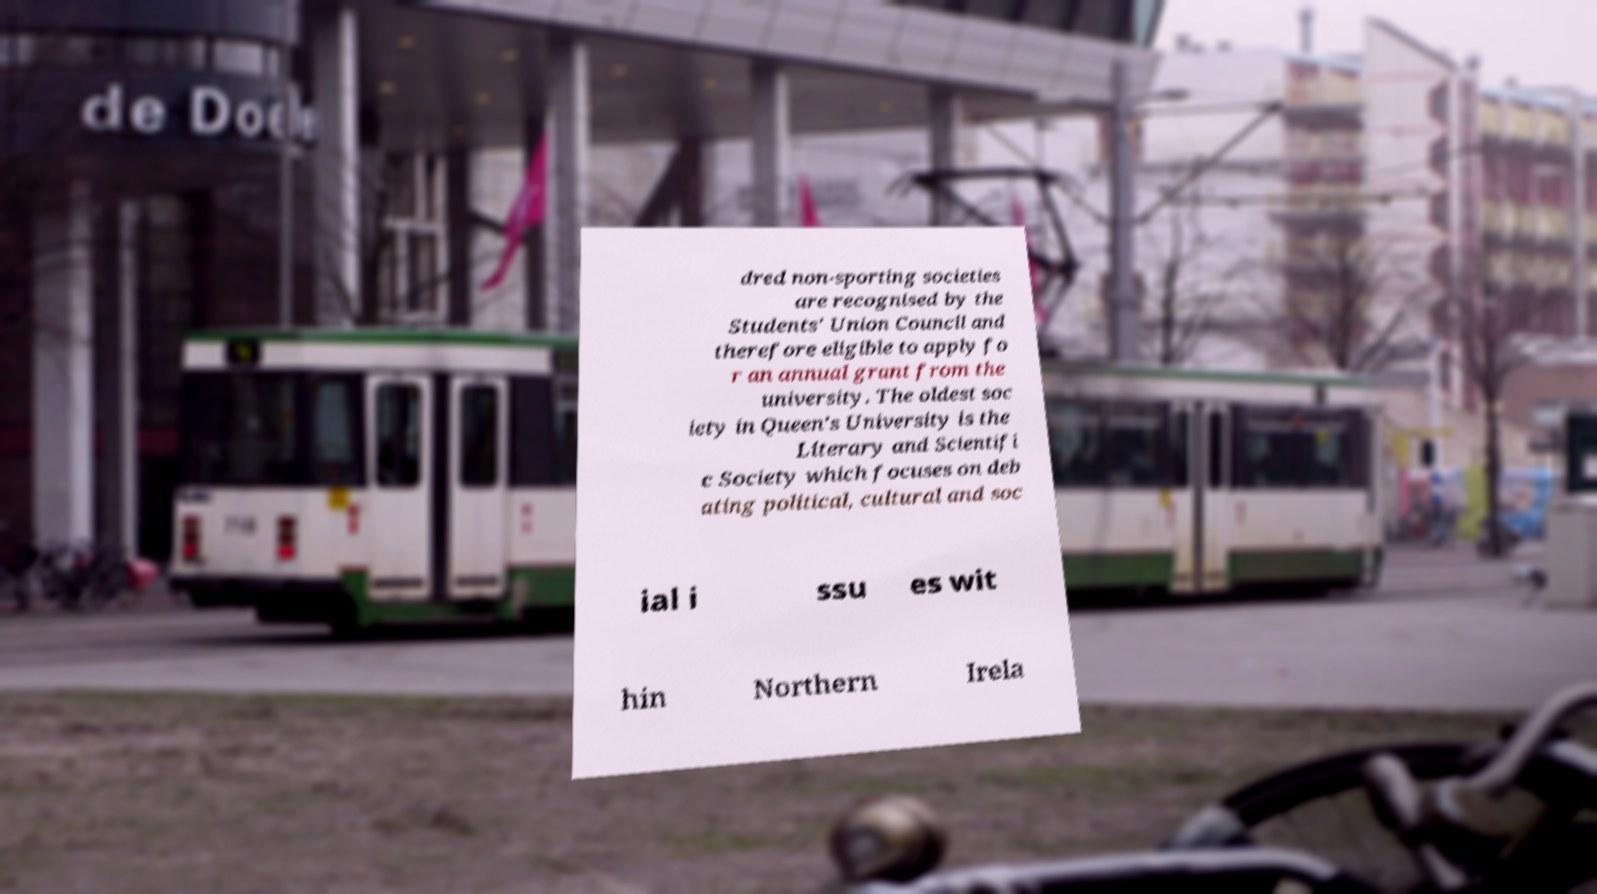Could you extract and type out the text from this image? dred non-sporting societies are recognised by the Students' Union Council and therefore eligible to apply fo r an annual grant from the university. The oldest soc iety in Queen's University is the Literary and Scientifi c Society which focuses on deb ating political, cultural and soc ial i ssu es wit hin Northern Irela 